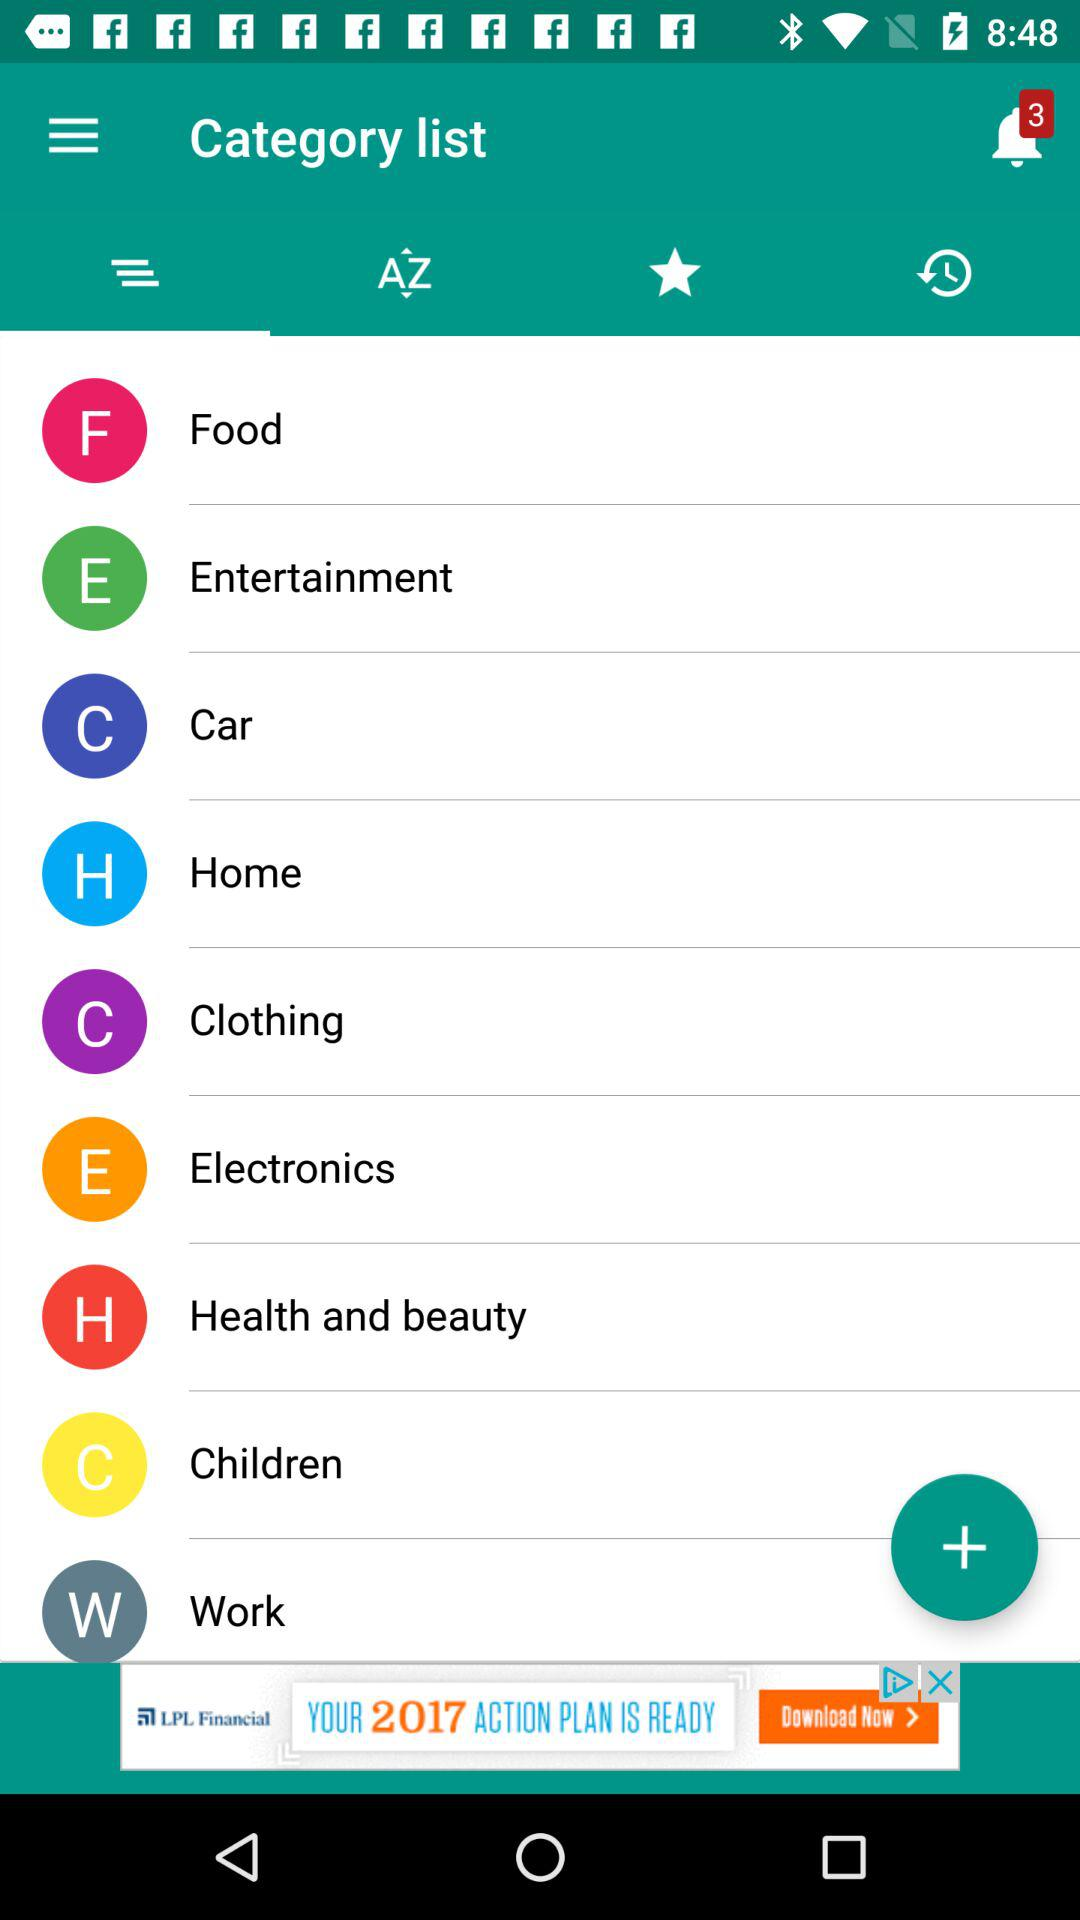Which tab is selected? The selected tab is "Category list". 